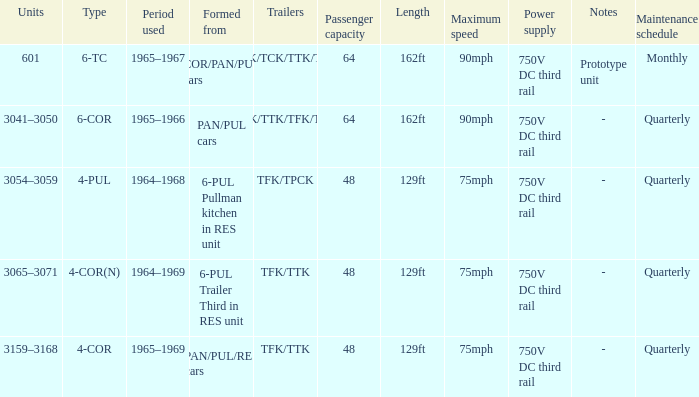Name the formed that has type of 4-cor PAN/PUL/RES cars. 